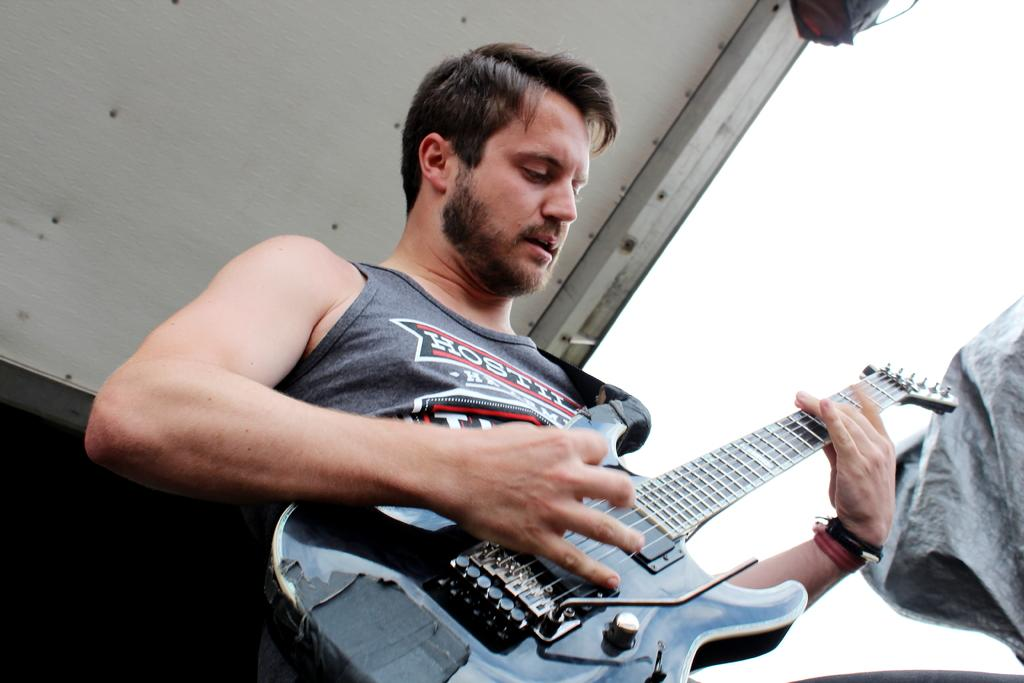How many people are in the image? There is one person in the picture. What is the person holding in the image? The person is holding a guitar. What is the person wearing in the image? The person is wearing a grey shirt. What type of coat is the laborer wearing in the image? There is no laborer or coat present in the image. How does the person walk while holding the guitar in the image? The person is not walking in the image; they are stationary while holding the guitar. 